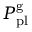<formula> <loc_0><loc_0><loc_500><loc_500>P _ { p l } ^ { g }</formula> 